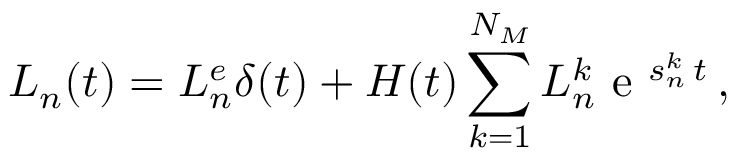Convert formula to latex. <formula><loc_0><loc_0><loc_500><loc_500>L _ { n } ( t ) = L _ { n } ^ { e } \delta ( t ) + H ( t ) \sum _ { k = 1 } ^ { N _ { M } } { L _ { n } ^ { k } } e ^ { s _ { n } ^ { k } \, t } \, ,</formula> 